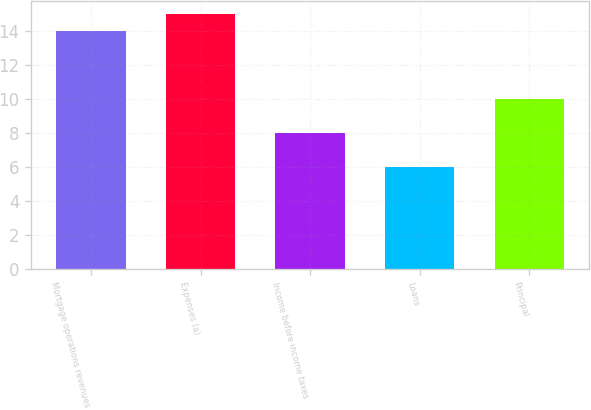<chart> <loc_0><loc_0><loc_500><loc_500><bar_chart><fcel>Mortgage operations revenues<fcel>Expenses (a)<fcel>Income before income taxes<fcel>Loans<fcel>Principal<nl><fcel>14<fcel>15<fcel>8<fcel>6<fcel>10<nl></chart> 